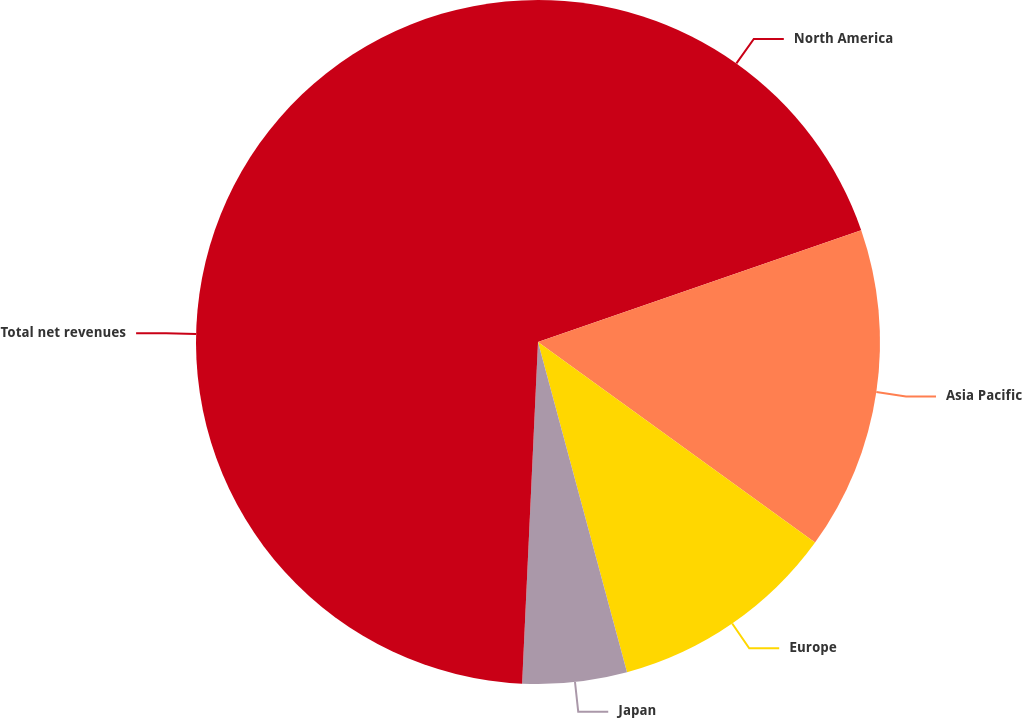Convert chart to OTSL. <chart><loc_0><loc_0><loc_500><loc_500><pie_chart><fcel>North America<fcel>Asia Pacific<fcel>Europe<fcel>Japan<fcel>Total net revenues<nl><fcel>19.7%<fcel>15.27%<fcel>10.84%<fcel>4.93%<fcel>49.26%<nl></chart> 